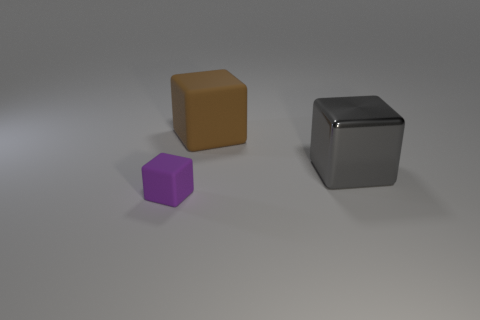Add 1 metal things. How many objects exist? 4 Add 1 small purple rubber cubes. How many small purple rubber cubes are left? 2 Add 1 large blue blocks. How many large blue blocks exist? 1 Subtract 0 red cylinders. How many objects are left? 3 Subtract all large gray shiny balls. Subtract all matte cubes. How many objects are left? 1 